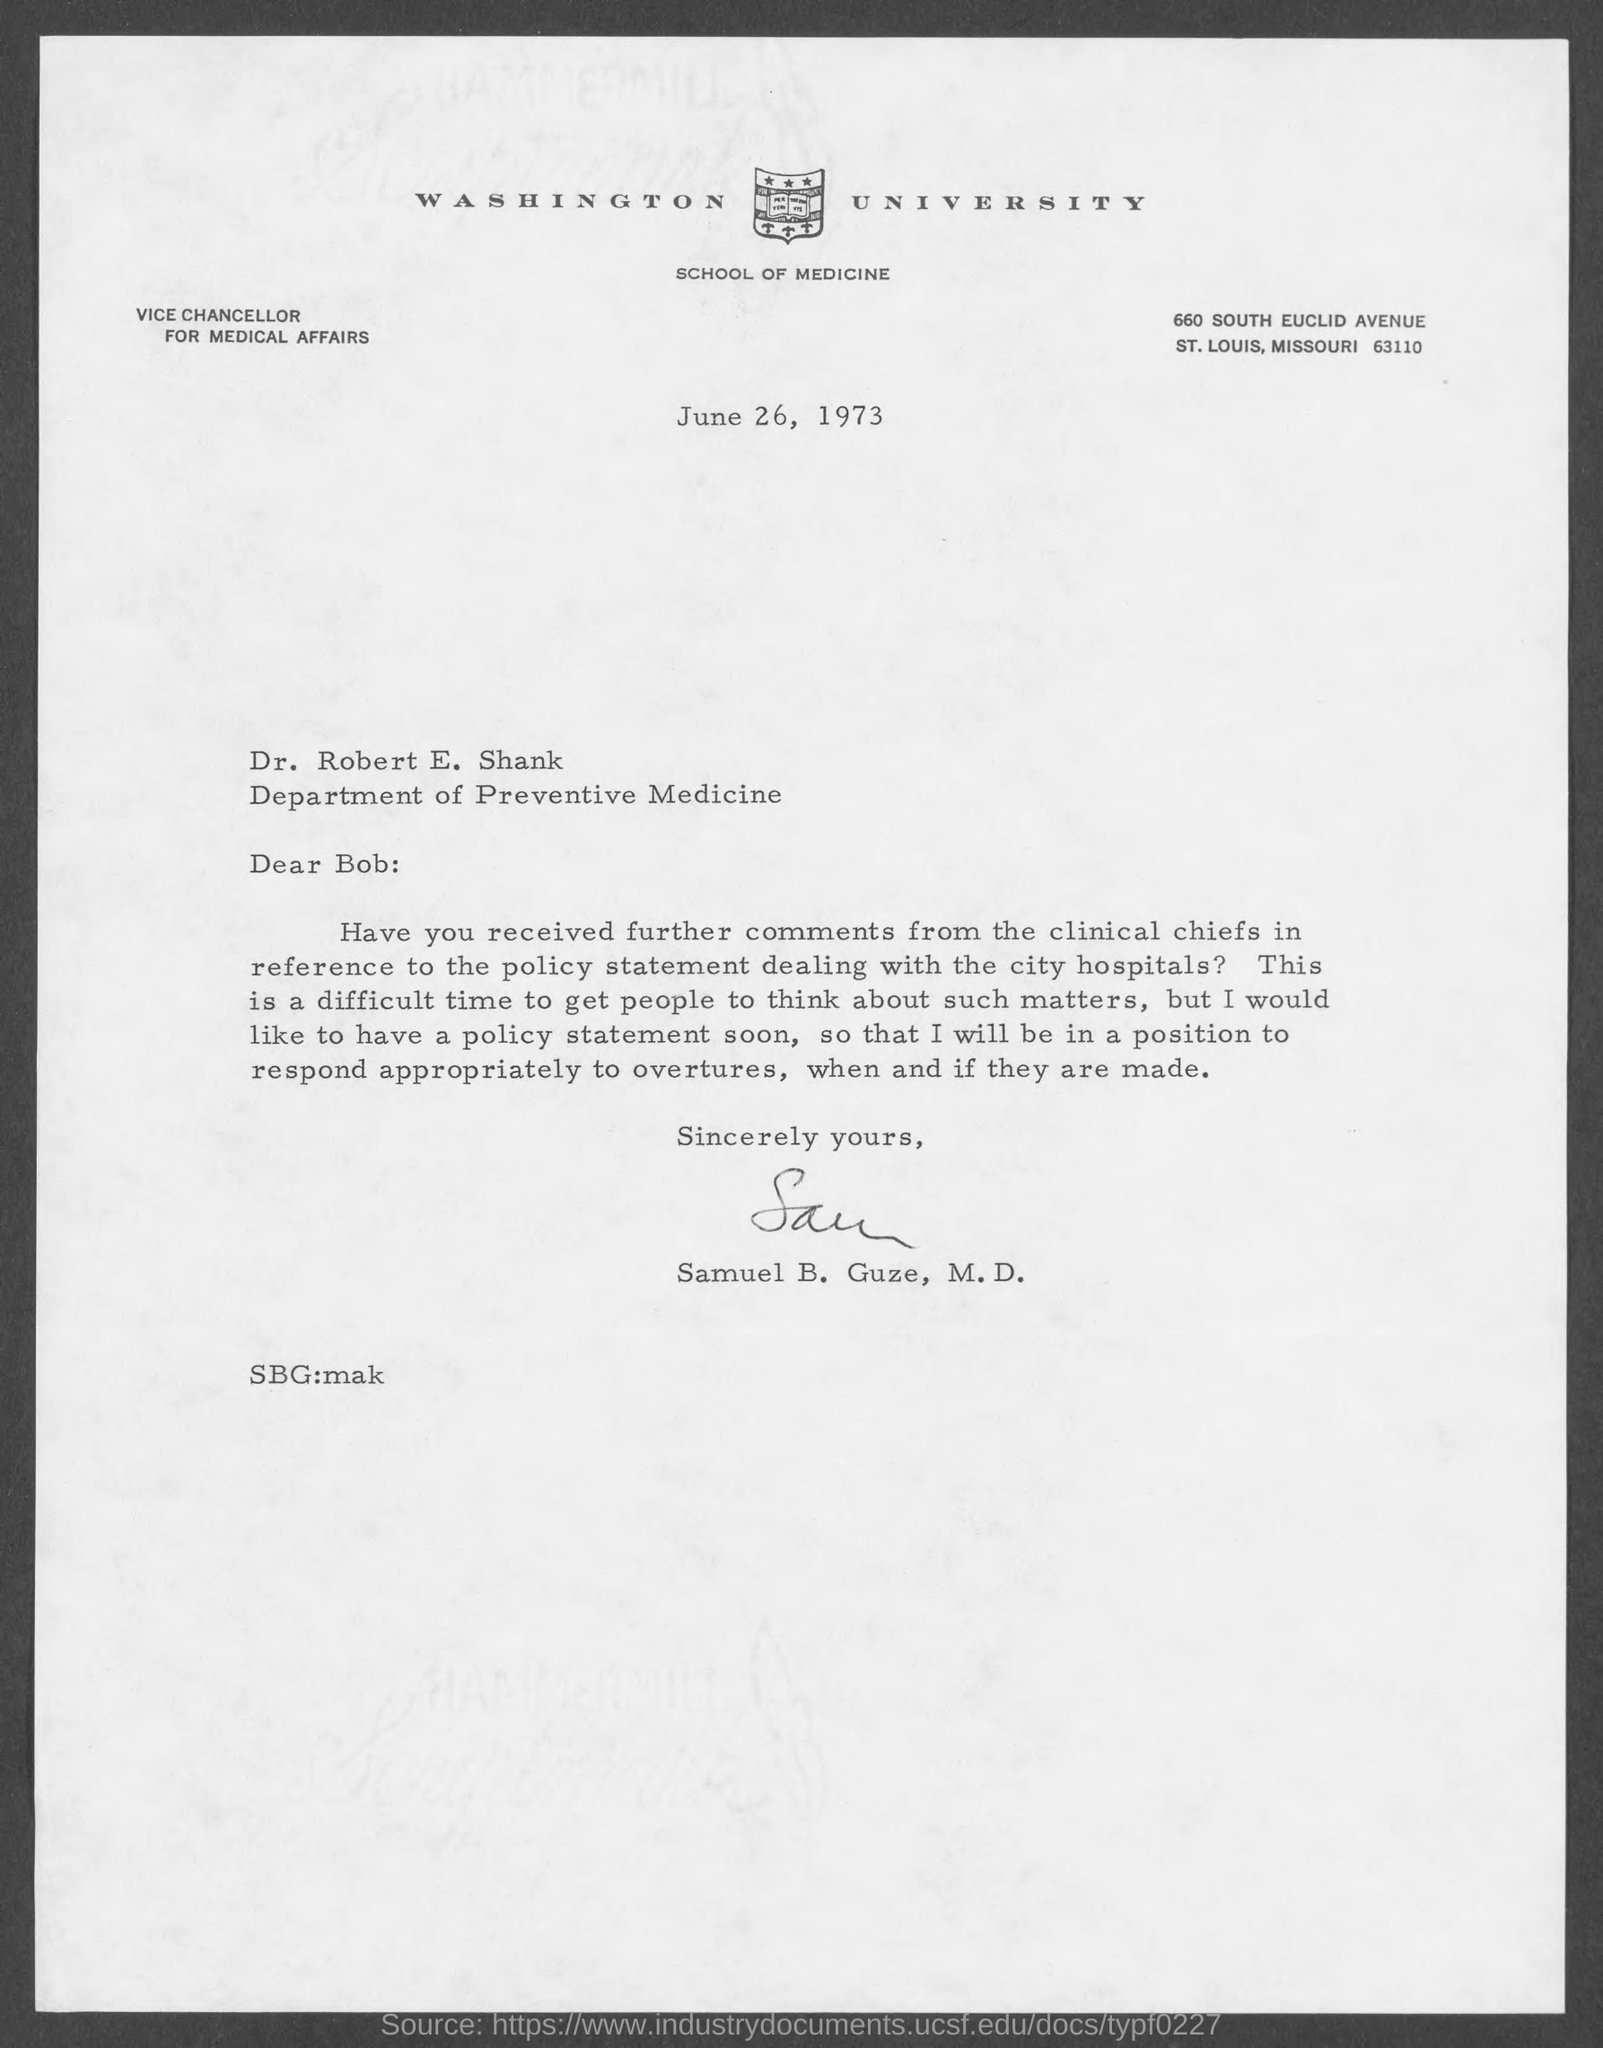Draw attention to some important aspects in this diagram. The date mentioned in this letter is June 26, 1973. The letter heading states that Washington University is mentioned. 